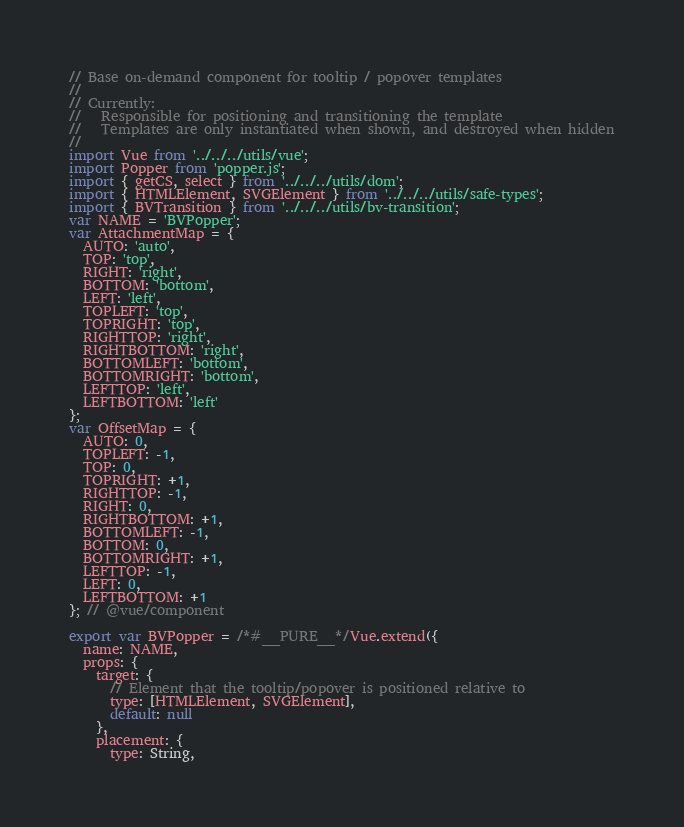Convert code to text. <code><loc_0><loc_0><loc_500><loc_500><_JavaScript_>// Base on-demand component for tooltip / popover templates
//
// Currently:
//   Responsible for positioning and transitioning the template
//   Templates are only instantiated when shown, and destroyed when hidden
//
import Vue from '../../../utils/vue';
import Popper from 'popper.js';
import { getCS, select } from '../../../utils/dom';
import { HTMLElement, SVGElement } from '../../../utils/safe-types';
import { BVTransition } from '../../../utils/bv-transition';
var NAME = 'BVPopper';
var AttachmentMap = {
  AUTO: 'auto',
  TOP: 'top',
  RIGHT: 'right',
  BOTTOM: 'bottom',
  LEFT: 'left',
  TOPLEFT: 'top',
  TOPRIGHT: 'top',
  RIGHTTOP: 'right',
  RIGHTBOTTOM: 'right',
  BOTTOMLEFT: 'bottom',
  BOTTOMRIGHT: 'bottom',
  LEFTTOP: 'left',
  LEFTBOTTOM: 'left'
};
var OffsetMap = {
  AUTO: 0,
  TOPLEFT: -1,
  TOP: 0,
  TOPRIGHT: +1,
  RIGHTTOP: -1,
  RIGHT: 0,
  RIGHTBOTTOM: +1,
  BOTTOMLEFT: -1,
  BOTTOM: 0,
  BOTTOMRIGHT: +1,
  LEFTTOP: -1,
  LEFT: 0,
  LEFTBOTTOM: +1
}; // @vue/component

export var BVPopper = /*#__PURE__*/Vue.extend({
  name: NAME,
  props: {
    target: {
      // Element that the tooltip/popover is positioned relative to
      type: [HTMLElement, SVGElement],
      default: null
    },
    placement: {
      type: String,</code> 